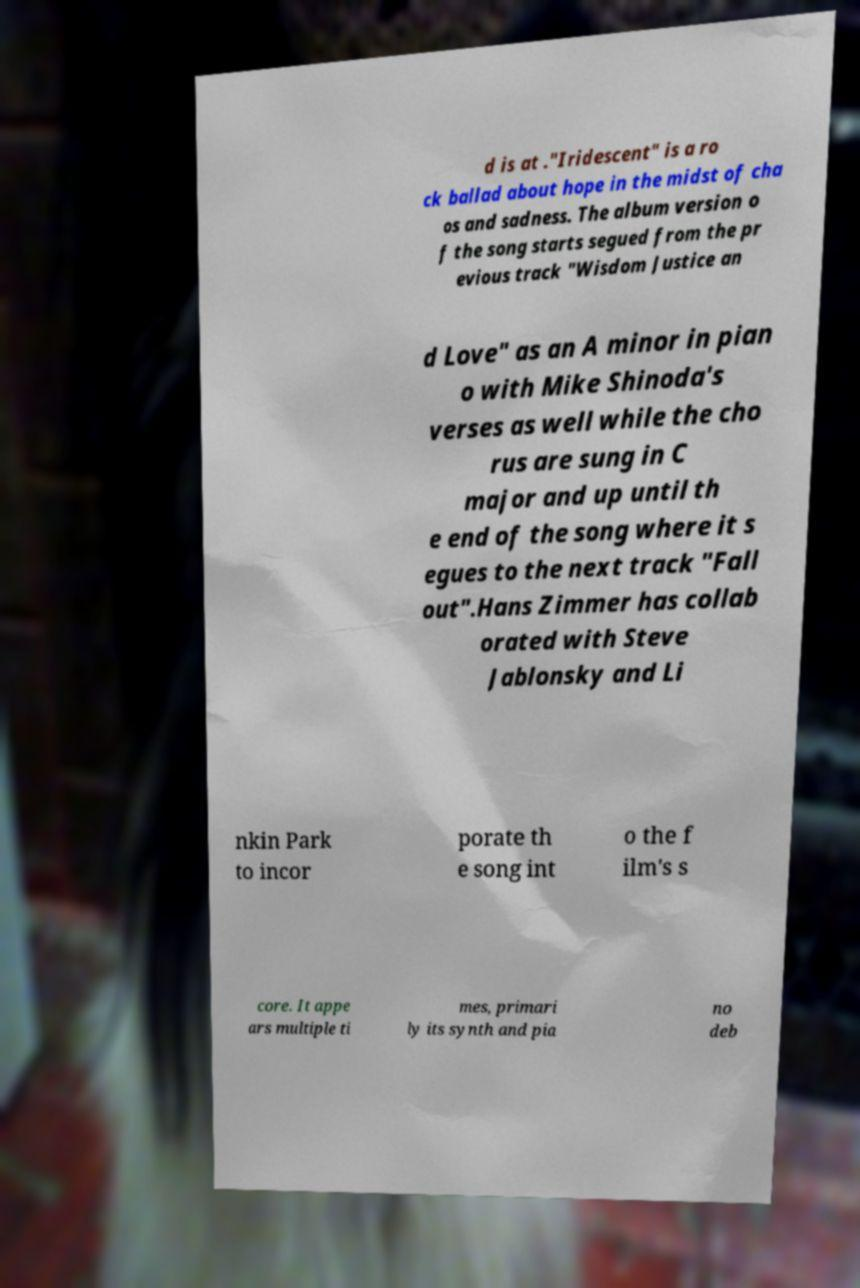Can you read and provide the text displayed in the image?This photo seems to have some interesting text. Can you extract and type it out for me? d is at ."Iridescent" is a ro ck ballad about hope in the midst of cha os and sadness. The album version o f the song starts segued from the pr evious track "Wisdom Justice an d Love" as an A minor in pian o with Mike Shinoda's verses as well while the cho rus are sung in C major and up until th e end of the song where it s egues to the next track "Fall out".Hans Zimmer has collab orated with Steve Jablonsky and Li nkin Park to incor porate th e song int o the f ilm's s core. It appe ars multiple ti mes, primari ly its synth and pia no deb 